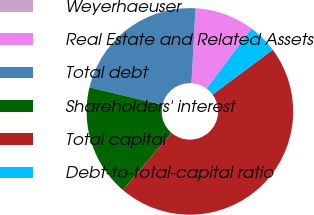Convert chart to OTSL. <chart><loc_0><loc_0><loc_500><loc_500><pie_chart><fcel>Weyerhaeuser<fcel>Real Estate and Related Assets<fcel>Total debt<fcel>Shareholders' interest<fcel>Total capital<fcel>Debt-to-total-capital ratio<nl><fcel>0.01%<fcel>9.29%<fcel>22.14%<fcel>17.49%<fcel>46.43%<fcel>4.65%<nl></chart> 